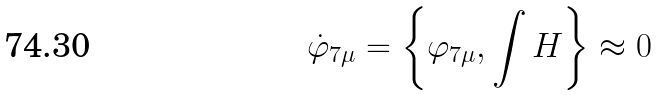<formula> <loc_0><loc_0><loc_500><loc_500>\dot { \varphi } _ { 7 \mu } = \left \{ \varphi _ { 7 \mu } , \int H \right \} \approx 0</formula> 